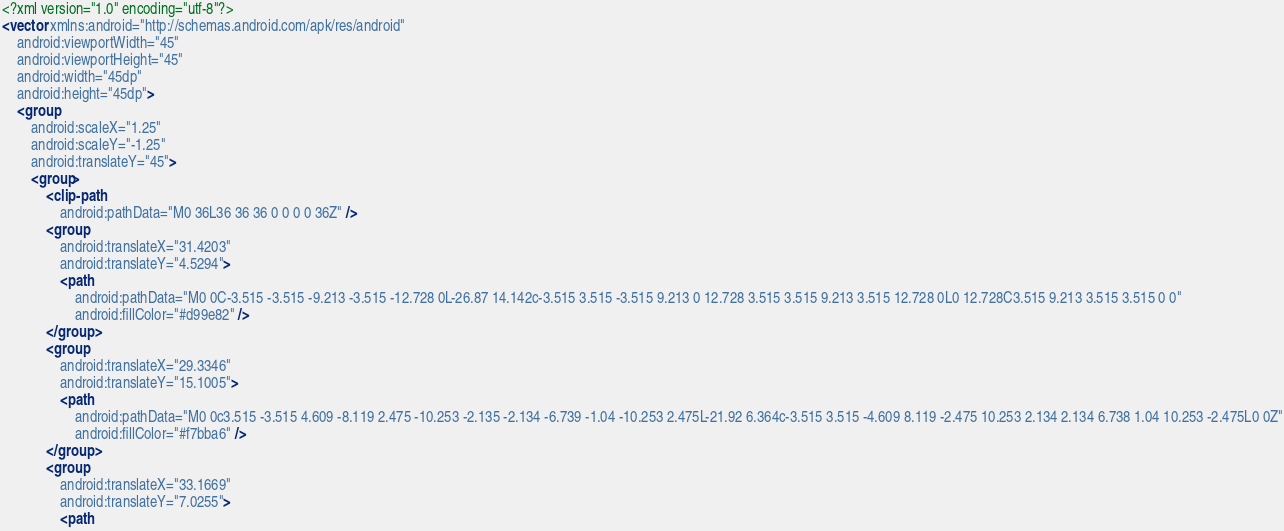<code> <loc_0><loc_0><loc_500><loc_500><_XML_><?xml version="1.0" encoding="utf-8"?>
<vector xmlns:android="http://schemas.android.com/apk/res/android"
    android:viewportWidth="45"
    android:viewportHeight="45"
    android:width="45dp"
    android:height="45dp">
    <group
        android:scaleX="1.25"
        android:scaleY="-1.25"
        android:translateY="45">
        <group>
            <clip-path
                android:pathData="M0 36L36 36 36 0 0 0 0 36Z" />
            <group
                android:translateX="31.4203"
                android:translateY="4.5294">
                <path
                    android:pathData="M0 0C-3.515 -3.515 -9.213 -3.515 -12.728 0L-26.87 14.142c-3.515 3.515 -3.515 9.213 0 12.728 3.515 3.515 9.213 3.515 12.728 0L0 12.728C3.515 9.213 3.515 3.515 0 0"
                    android:fillColor="#d99e82" />
            </group>
            <group
                android:translateX="29.3346"
                android:translateY="15.1005">
                <path
                    android:pathData="M0 0c3.515 -3.515 4.609 -8.119 2.475 -10.253 -2.135 -2.134 -6.739 -1.04 -10.253 2.475L-21.92 6.364c-3.515 3.515 -4.609 8.119 -2.475 10.253 2.134 2.134 6.738 1.04 10.253 -2.475L0 0Z"
                    android:fillColor="#f7bba6" />
            </group>
            <group
                android:translateX="33.1669"
                android:translateY="7.0255">
                <path</code> 